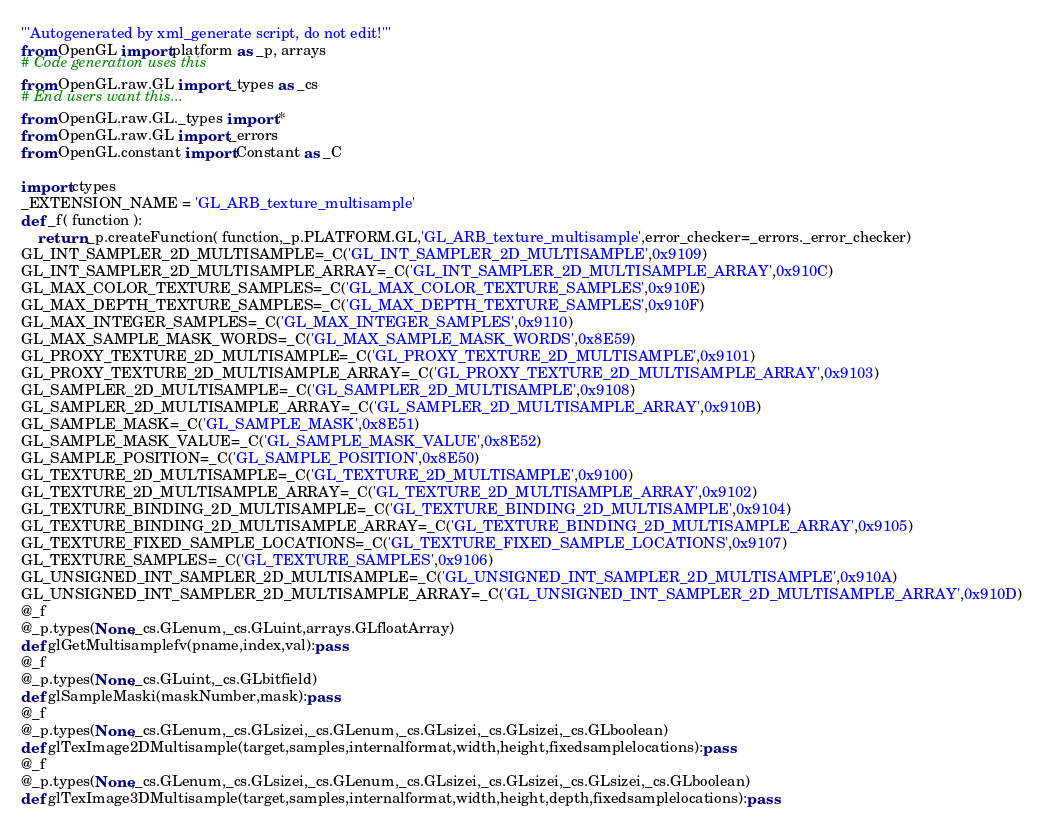<code> <loc_0><loc_0><loc_500><loc_500><_Python_>'''Autogenerated by xml_generate script, do not edit!'''
from OpenGL import platform as _p, arrays
# Code generation uses this
from OpenGL.raw.GL import _types as _cs
# End users want this...
from OpenGL.raw.GL._types import *
from OpenGL.raw.GL import _errors
from OpenGL.constant import Constant as _C

import ctypes
_EXTENSION_NAME = 'GL_ARB_texture_multisample'
def _f( function ):
    return _p.createFunction( function,_p.PLATFORM.GL,'GL_ARB_texture_multisample',error_checker=_errors._error_checker)
GL_INT_SAMPLER_2D_MULTISAMPLE=_C('GL_INT_SAMPLER_2D_MULTISAMPLE',0x9109)
GL_INT_SAMPLER_2D_MULTISAMPLE_ARRAY=_C('GL_INT_SAMPLER_2D_MULTISAMPLE_ARRAY',0x910C)
GL_MAX_COLOR_TEXTURE_SAMPLES=_C('GL_MAX_COLOR_TEXTURE_SAMPLES',0x910E)
GL_MAX_DEPTH_TEXTURE_SAMPLES=_C('GL_MAX_DEPTH_TEXTURE_SAMPLES',0x910F)
GL_MAX_INTEGER_SAMPLES=_C('GL_MAX_INTEGER_SAMPLES',0x9110)
GL_MAX_SAMPLE_MASK_WORDS=_C('GL_MAX_SAMPLE_MASK_WORDS',0x8E59)
GL_PROXY_TEXTURE_2D_MULTISAMPLE=_C('GL_PROXY_TEXTURE_2D_MULTISAMPLE',0x9101)
GL_PROXY_TEXTURE_2D_MULTISAMPLE_ARRAY=_C('GL_PROXY_TEXTURE_2D_MULTISAMPLE_ARRAY',0x9103)
GL_SAMPLER_2D_MULTISAMPLE=_C('GL_SAMPLER_2D_MULTISAMPLE',0x9108)
GL_SAMPLER_2D_MULTISAMPLE_ARRAY=_C('GL_SAMPLER_2D_MULTISAMPLE_ARRAY',0x910B)
GL_SAMPLE_MASK=_C('GL_SAMPLE_MASK',0x8E51)
GL_SAMPLE_MASK_VALUE=_C('GL_SAMPLE_MASK_VALUE',0x8E52)
GL_SAMPLE_POSITION=_C('GL_SAMPLE_POSITION',0x8E50)
GL_TEXTURE_2D_MULTISAMPLE=_C('GL_TEXTURE_2D_MULTISAMPLE',0x9100)
GL_TEXTURE_2D_MULTISAMPLE_ARRAY=_C('GL_TEXTURE_2D_MULTISAMPLE_ARRAY',0x9102)
GL_TEXTURE_BINDING_2D_MULTISAMPLE=_C('GL_TEXTURE_BINDING_2D_MULTISAMPLE',0x9104)
GL_TEXTURE_BINDING_2D_MULTISAMPLE_ARRAY=_C('GL_TEXTURE_BINDING_2D_MULTISAMPLE_ARRAY',0x9105)
GL_TEXTURE_FIXED_SAMPLE_LOCATIONS=_C('GL_TEXTURE_FIXED_SAMPLE_LOCATIONS',0x9107)
GL_TEXTURE_SAMPLES=_C('GL_TEXTURE_SAMPLES',0x9106)
GL_UNSIGNED_INT_SAMPLER_2D_MULTISAMPLE=_C('GL_UNSIGNED_INT_SAMPLER_2D_MULTISAMPLE',0x910A)
GL_UNSIGNED_INT_SAMPLER_2D_MULTISAMPLE_ARRAY=_C('GL_UNSIGNED_INT_SAMPLER_2D_MULTISAMPLE_ARRAY',0x910D)
@_f
@_p.types(None,_cs.GLenum,_cs.GLuint,arrays.GLfloatArray)
def glGetMultisamplefv(pname,index,val):pass
@_f
@_p.types(None,_cs.GLuint,_cs.GLbitfield)
def glSampleMaski(maskNumber,mask):pass
@_f
@_p.types(None,_cs.GLenum,_cs.GLsizei,_cs.GLenum,_cs.GLsizei,_cs.GLsizei,_cs.GLboolean)
def glTexImage2DMultisample(target,samples,internalformat,width,height,fixedsamplelocations):pass
@_f
@_p.types(None,_cs.GLenum,_cs.GLsizei,_cs.GLenum,_cs.GLsizei,_cs.GLsizei,_cs.GLsizei,_cs.GLboolean)
def glTexImage3DMultisample(target,samples,internalformat,width,height,depth,fixedsamplelocations):pass
</code> 